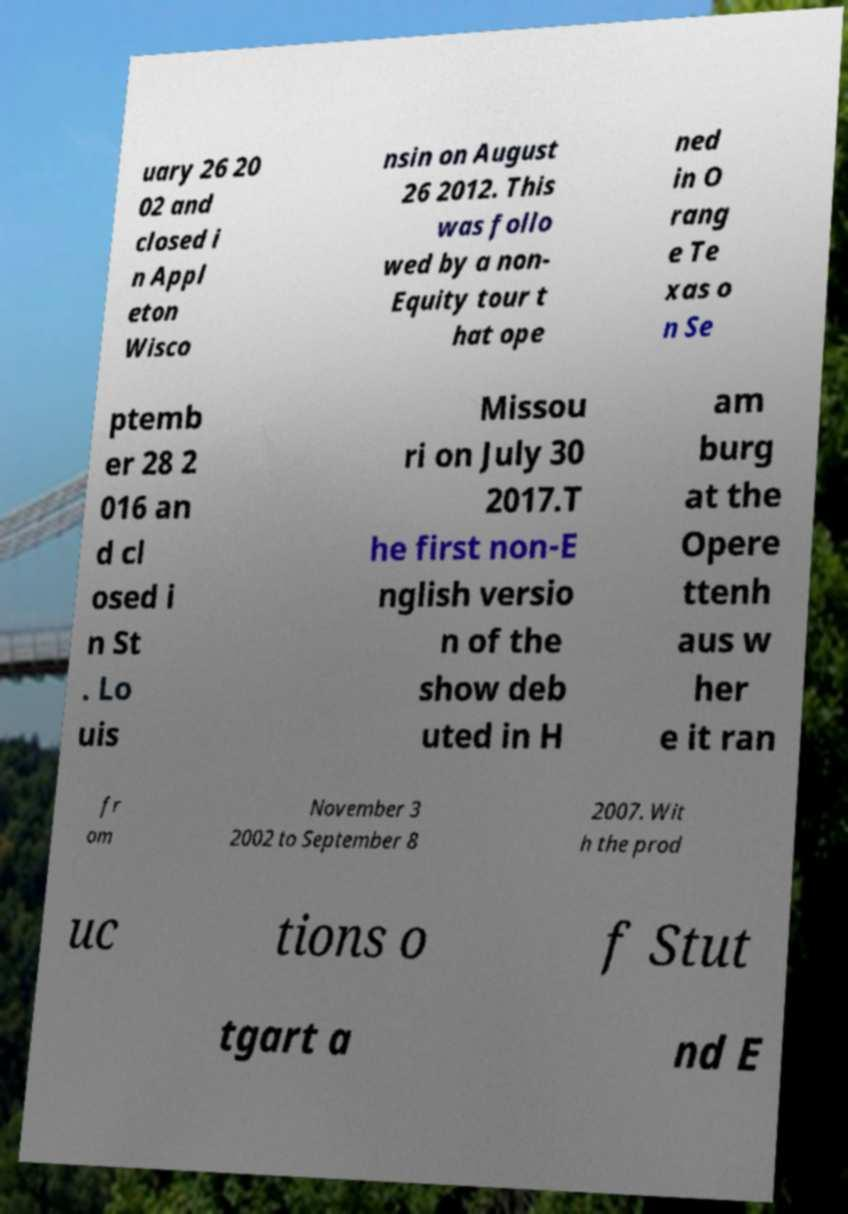Could you assist in decoding the text presented in this image and type it out clearly? uary 26 20 02 and closed i n Appl eton Wisco nsin on August 26 2012. This was follo wed by a non- Equity tour t hat ope ned in O rang e Te xas o n Se ptemb er 28 2 016 an d cl osed i n St . Lo uis Missou ri on July 30 2017.T he first non-E nglish versio n of the show deb uted in H am burg at the Opere ttenh aus w her e it ran fr om November 3 2002 to September 8 2007. Wit h the prod uc tions o f Stut tgart a nd E 